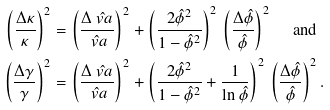<formula> <loc_0><loc_0><loc_500><loc_500>\left ( \frac { \Delta \kappa } { \kappa } \right ) ^ { 2 } & = \left ( \frac { \Delta \hat { \ v a } } { \hat { \ v a } } \right ) ^ { 2 } + \left ( \frac { 2 \hat { \phi } ^ { 2 } } { 1 - \hat { \phi } ^ { 2 } } \right ) ^ { 2 } \, \left ( \frac { \Delta \hat { \phi } } { \hat { \phi } } \right ) ^ { 2 } \text { \quad and} \\ \left ( \frac { \Delta \gamma } { \gamma } \right ) ^ { 2 } & = \left ( \frac { \Delta \hat { \ v a } } { \hat { \ v a } } \right ) ^ { 2 } + \left ( \frac { 2 \hat { \phi } ^ { 2 } } { 1 - \hat { \phi } ^ { 2 } } + \frac { 1 } { \ln \hat { \phi } } \right ) ^ { 2 } \, \left ( \frac { \Delta \hat { \phi } } { \hat { \phi } } \right ) ^ { 2 } .</formula> 